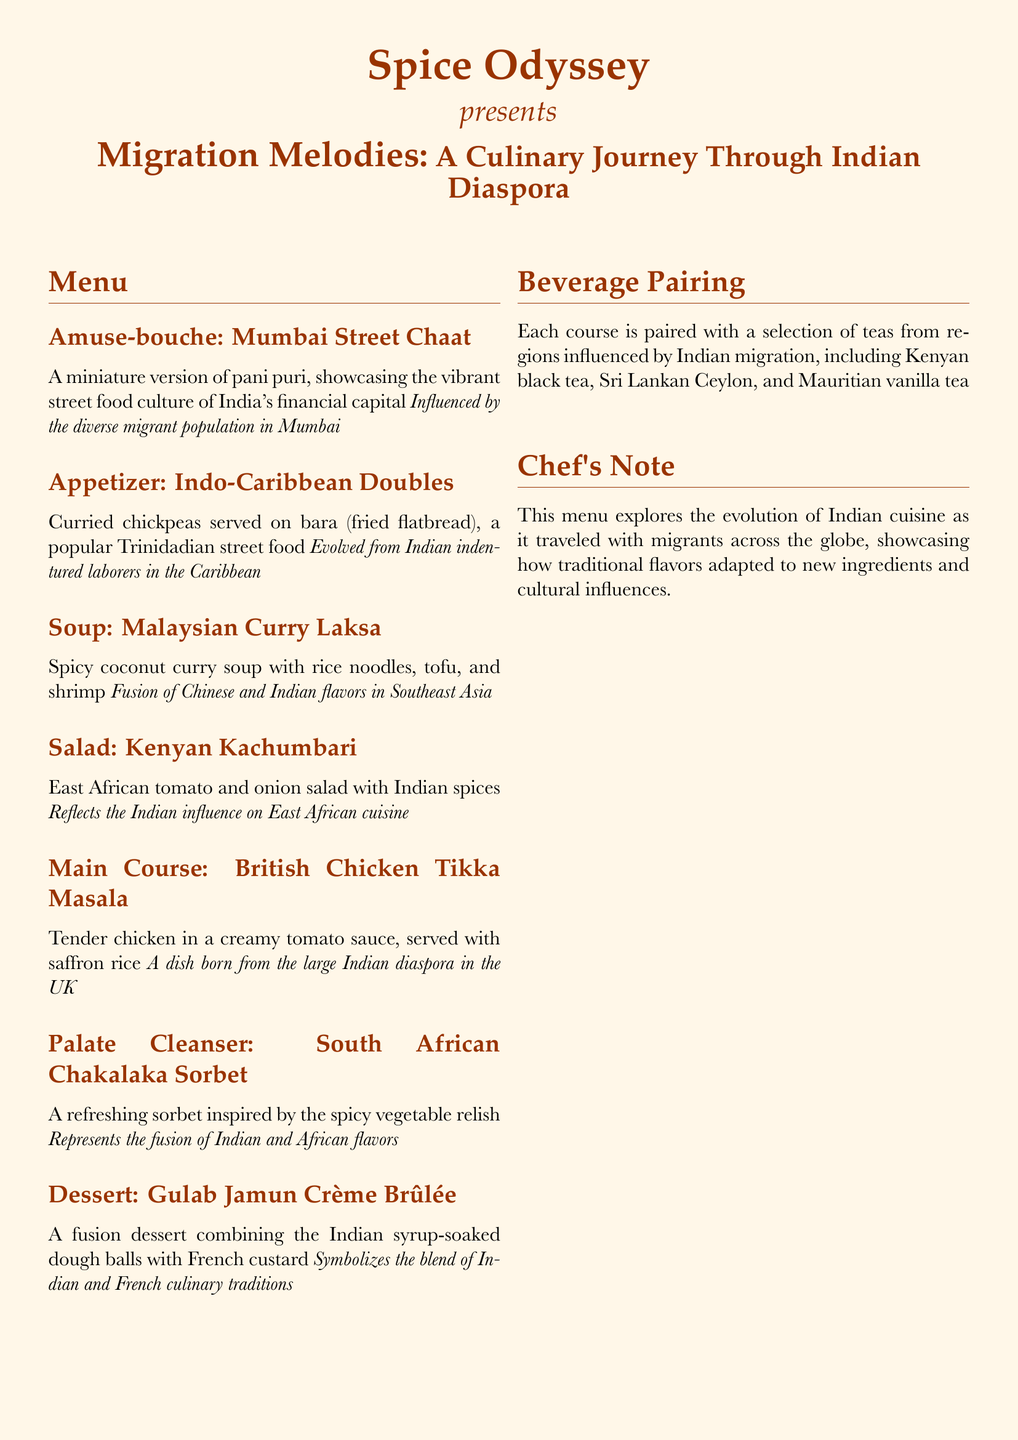what is the title of the tasting menu? The title of the tasting menu is "Migration Melodies: A Culinary Journey Through Indian Diaspora".
Answer: Migration Melodies: A Culinary Journey Through Indian Diaspora what is the first course in the menu? The first course in the menu is an amuse-bouche called "Mumbai Street Chaat".
Answer: Mumbai Street Chaat which country’s culinary influence is reflected in the "Indo-Caribbean Doubles"? The "Indo-Caribbean Doubles" reflects the influence of Indian cuisine in the Caribbean.
Answer: Indian what is paired with each course of the menu? Each course is paired with a selection of teas from regions influenced by Indian migration.
Answer: Teas how does the "British Chicken Tikka Masala" symbolize the Indian diaspora? The "British Chicken Tikka Masala" is a dish born from the large Indian diaspora in the UK.
Answer: Large Indian diaspora in the UK what type of cuisine does the "Malaysian Curry Laksa" represent? "Malaysian Curry Laksa" represents a fusion of Chinese and Indian flavors in Southeast Asia.
Answer: Fusion of Chinese and Indian flavors what is the palate cleanser in the tasting menu? The palate cleanser in the tasting menu is "South African Chakalaka Sorbet".
Answer: South African Chakalaka Sorbet what is unique about the dessert course? The dessert course is a fusion of Indian and French culinary traditions.
Answer: Fusion of Indian and French culinary traditions 